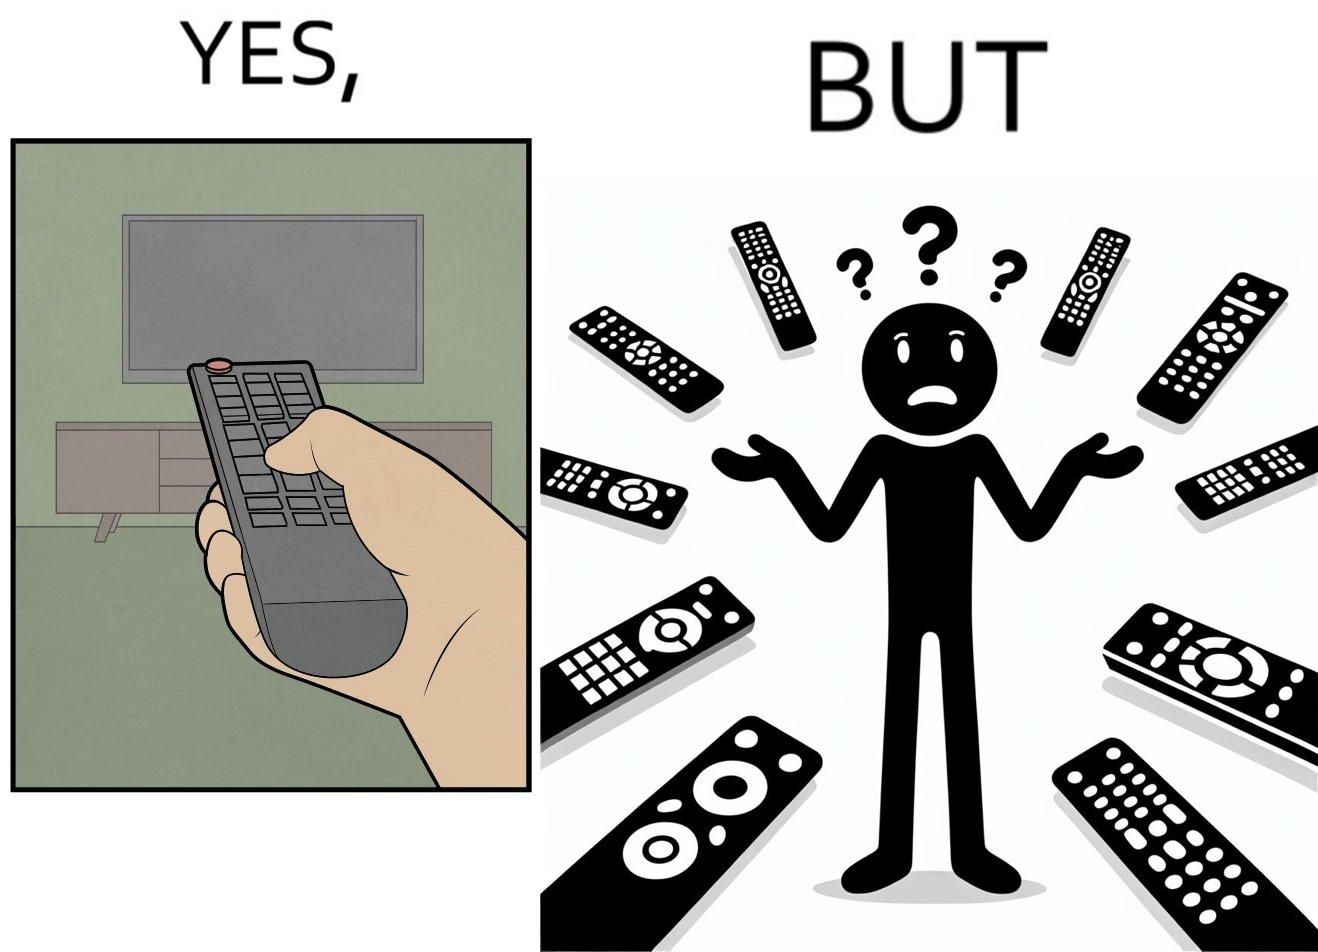What is shown in the left half versus the right half of this image? In the left part of the image: It is a remote being used to operate a TV In the right part of the image: It is an user confused between multiple remotes 